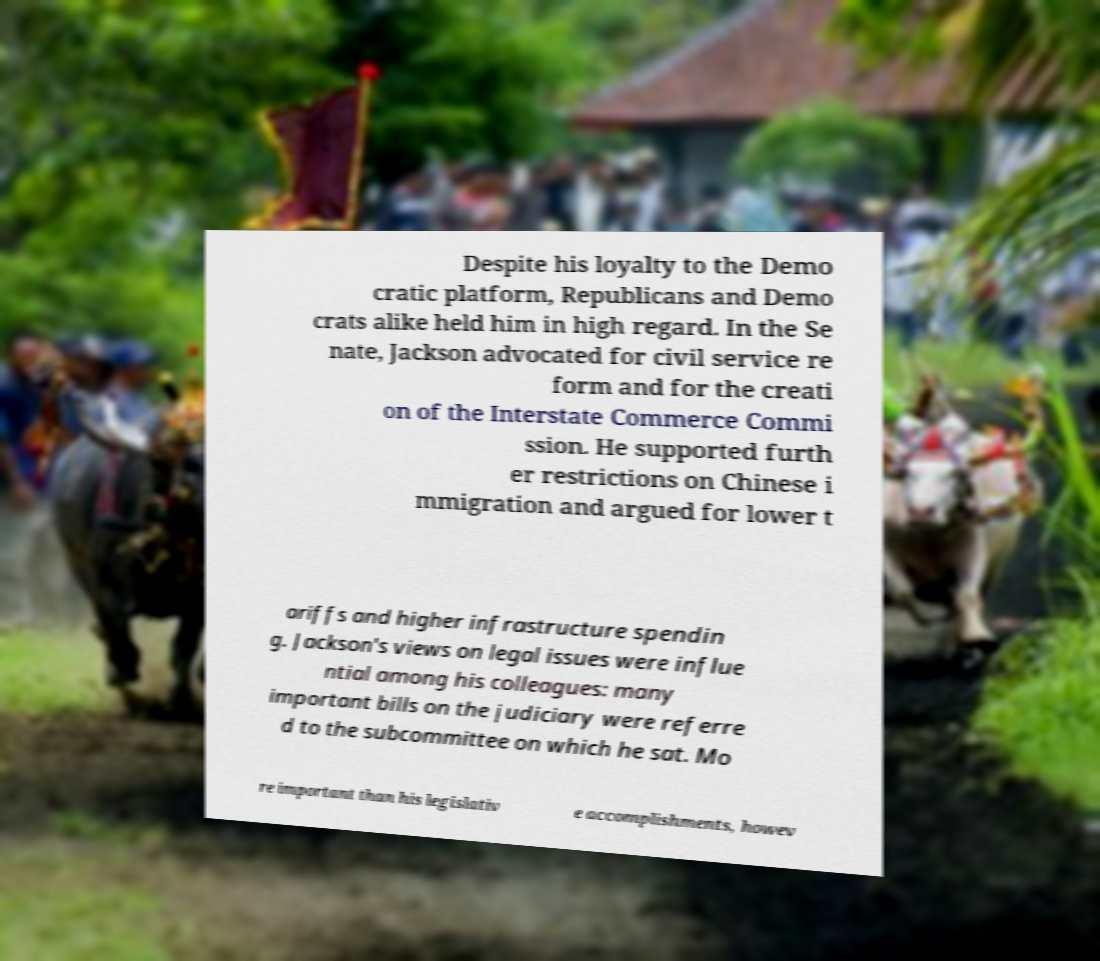Can you read and provide the text displayed in the image?This photo seems to have some interesting text. Can you extract and type it out for me? Despite his loyalty to the Demo cratic platform, Republicans and Demo crats alike held him in high regard. In the Se nate, Jackson advocated for civil service re form and for the creati on of the Interstate Commerce Commi ssion. He supported furth er restrictions on Chinese i mmigration and argued for lower t ariffs and higher infrastructure spendin g. Jackson's views on legal issues were influe ntial among his colleagues: many important bills on the judiciary were referre d to the subcommittee on which he sat. Mo re important than his legislativ e accomplishments, howev 